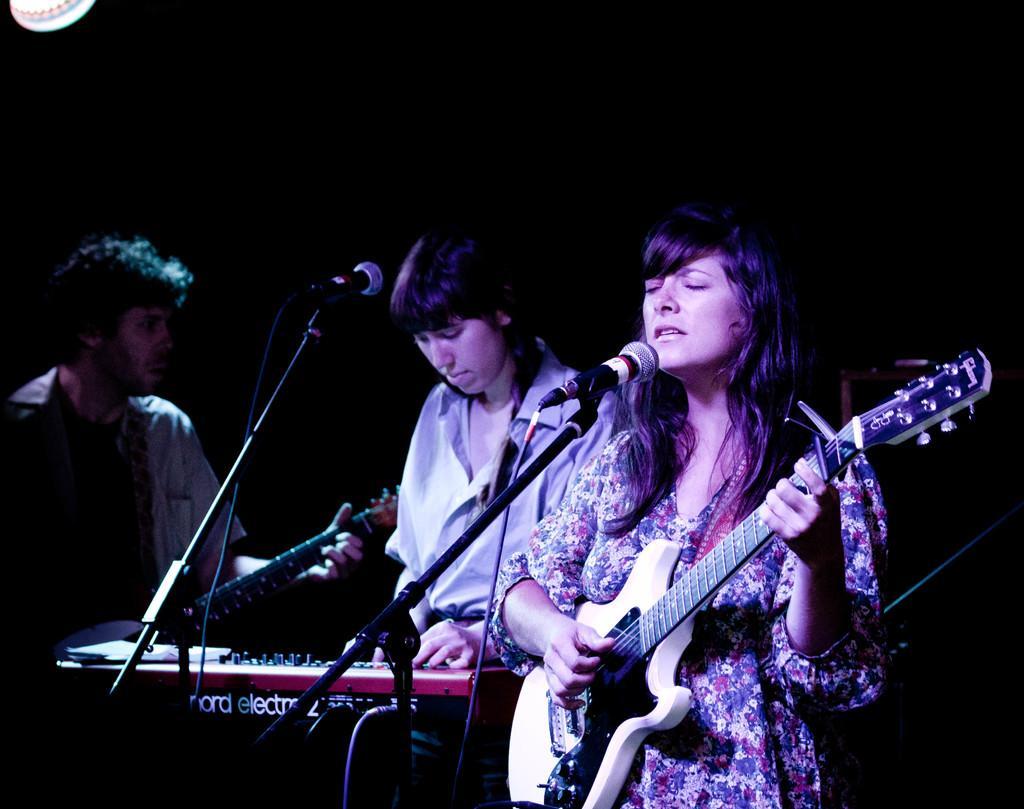Describe this image in one or two sentences. There are three persons standing. One woman is singing a song and playing guitar. The person in the middle is playing piano,and the person at the left side of the image is playing guitar. This is a mike stand with the mike. 